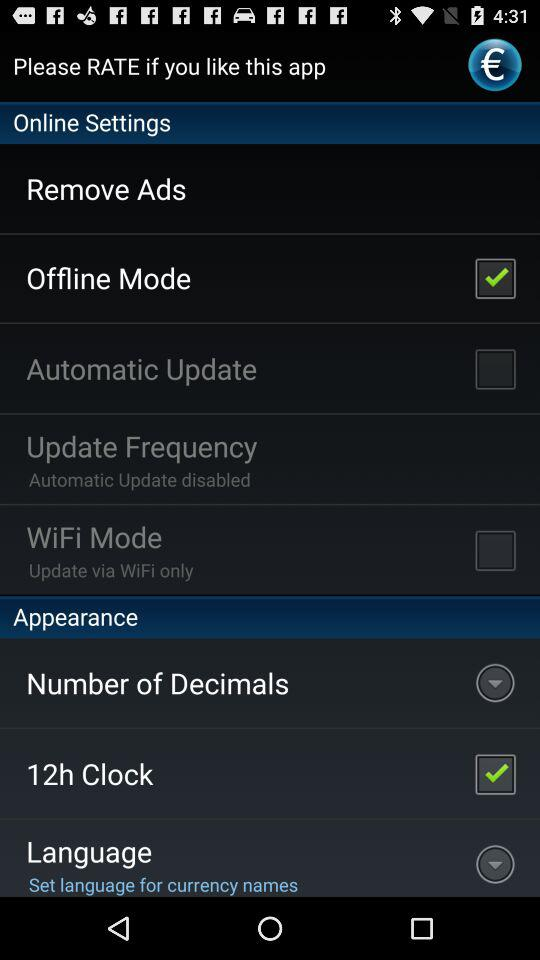What's the setting of update frequency? The setting of update frequency is "Automatic Update disabled". 